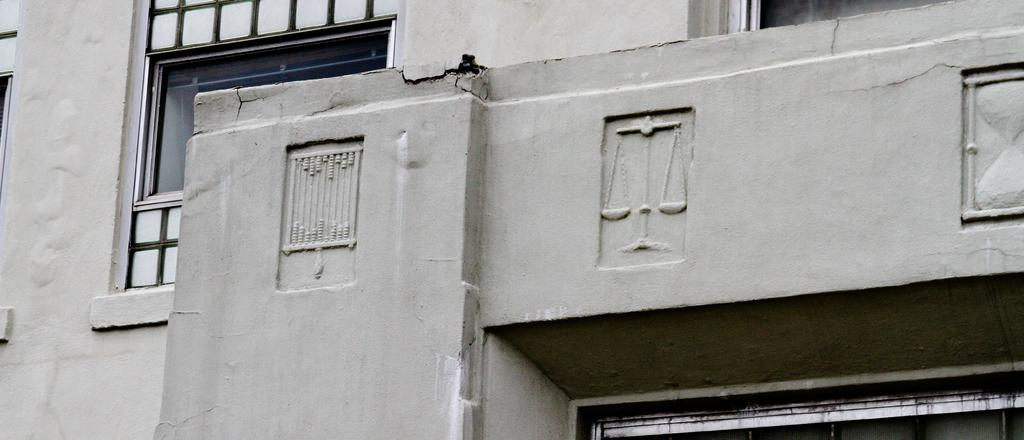What is located at the front of the image? There is a wall in the front of the image. What can be seen in the background of the image? There are windows visible in the background of the image. What type of fruit does the grandmother regret not bringing to the picnic in the image? There is no mention of a grandmother or a picnic in the image, so it is not possible to answer that question. 